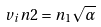<formula> <loc_0><loc_0><loc_500><loc_500>v _ { i } n 2 = n _ { 1 } \sqrt { \alpha }</formula> 